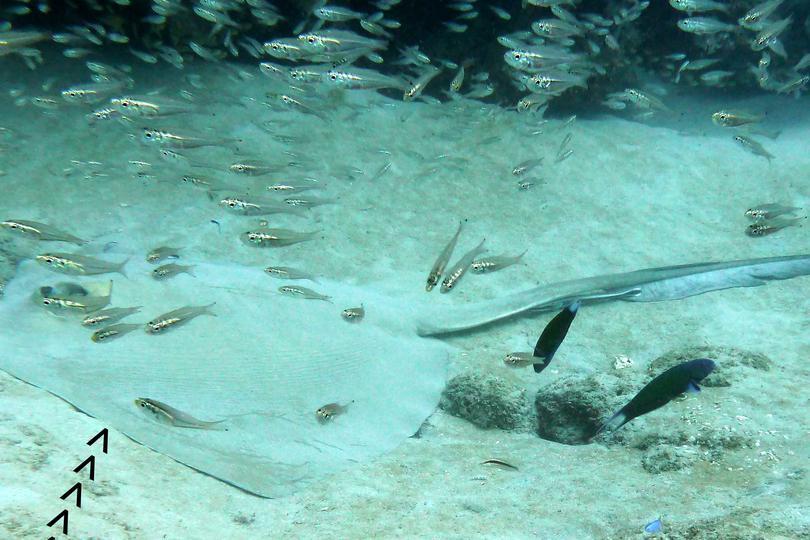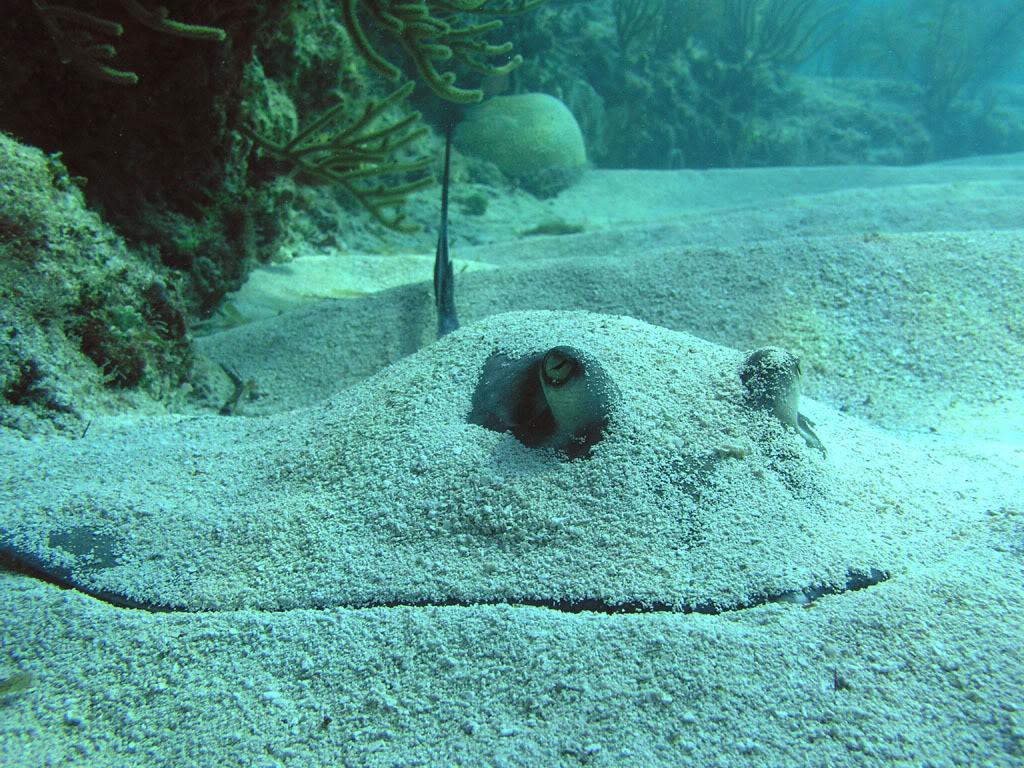The first image is the image on the left, the second image is the image on the right. Considering the images on both sides, is "There's a blue ray and a brown/grey ray, swimming over smooth sand." valid? Answer yes or no. No. The first image is the image on the left, the second image is the image on the right. Assess this claim about the two images: "An image shows one stingray facing rightward, which is not covered with sand.". Correct or not? Answer yes or no. No. 